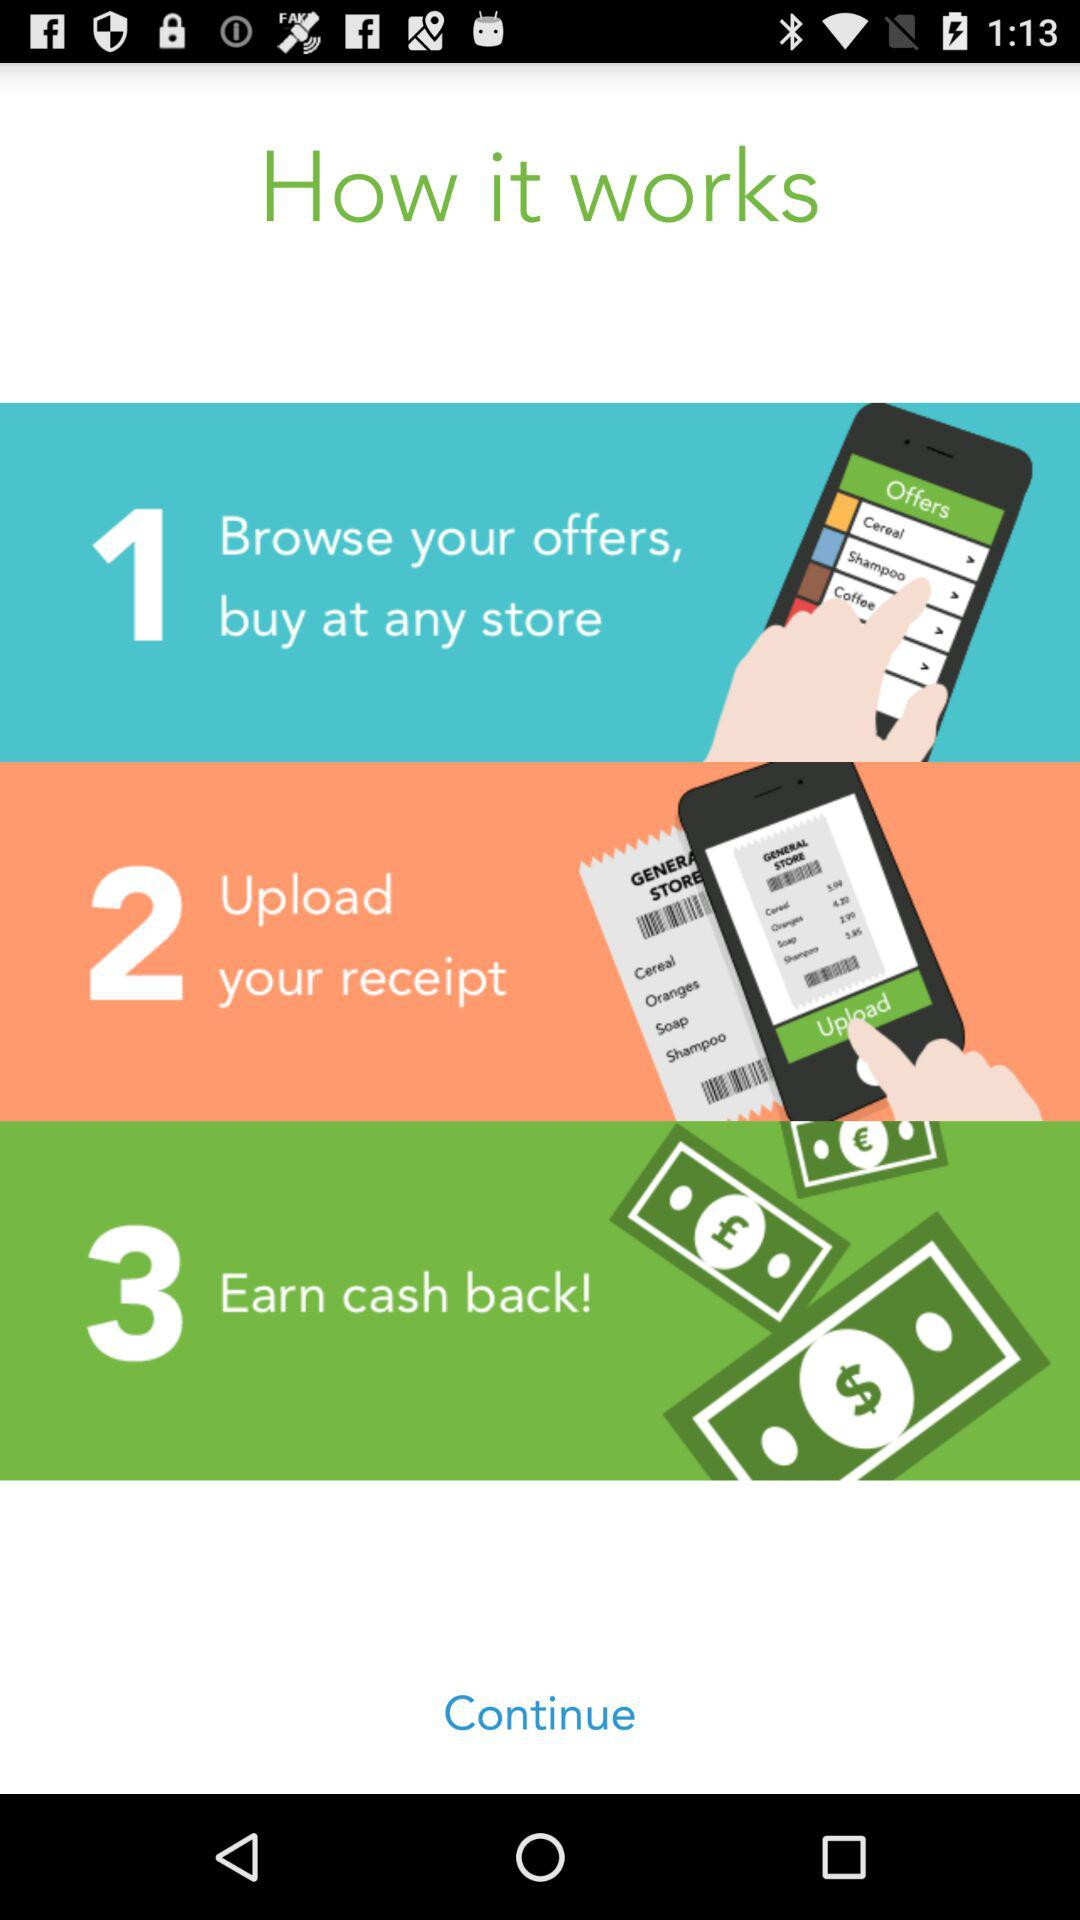What is the second step? The second step is "Upload your receipt". 